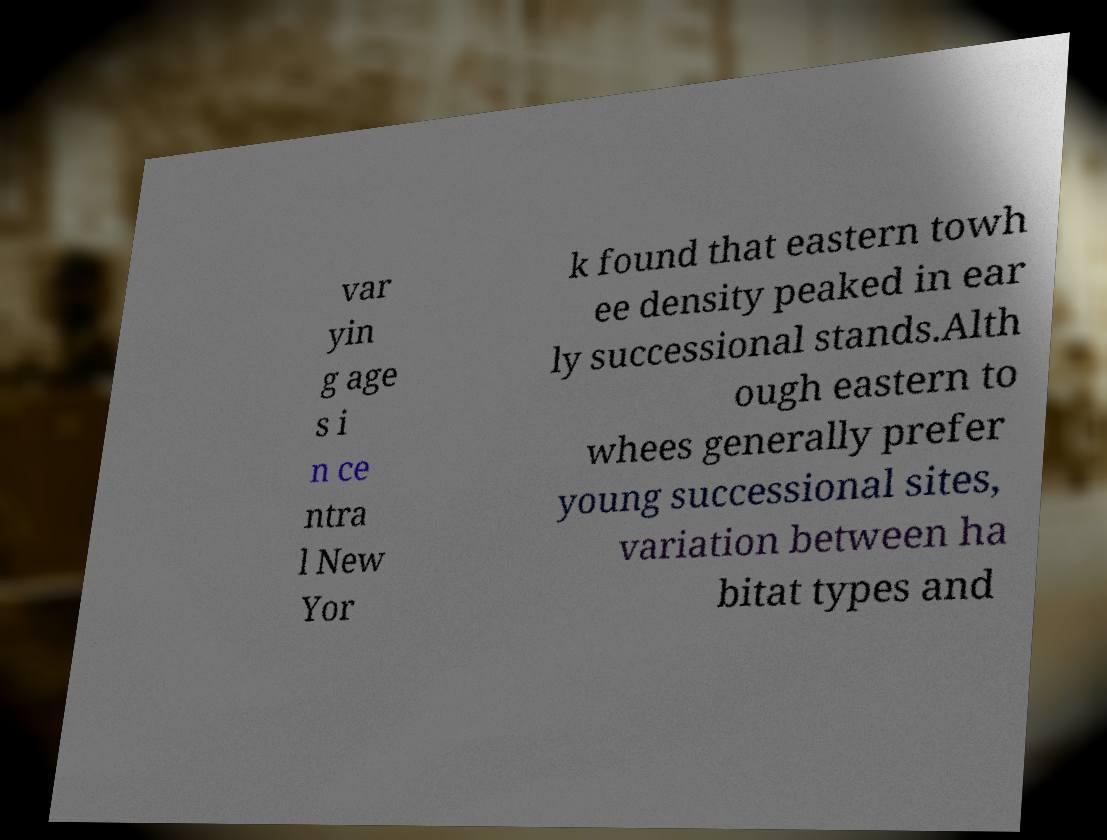Could you extract and type out the text from this image? var yin g age s i n ce ntra l New Yor k found that eastern towh ee density peaked in ear ly successional stands.Alth ough eastern to whees generally prefer young successional sites, variation between ha bitat types and 